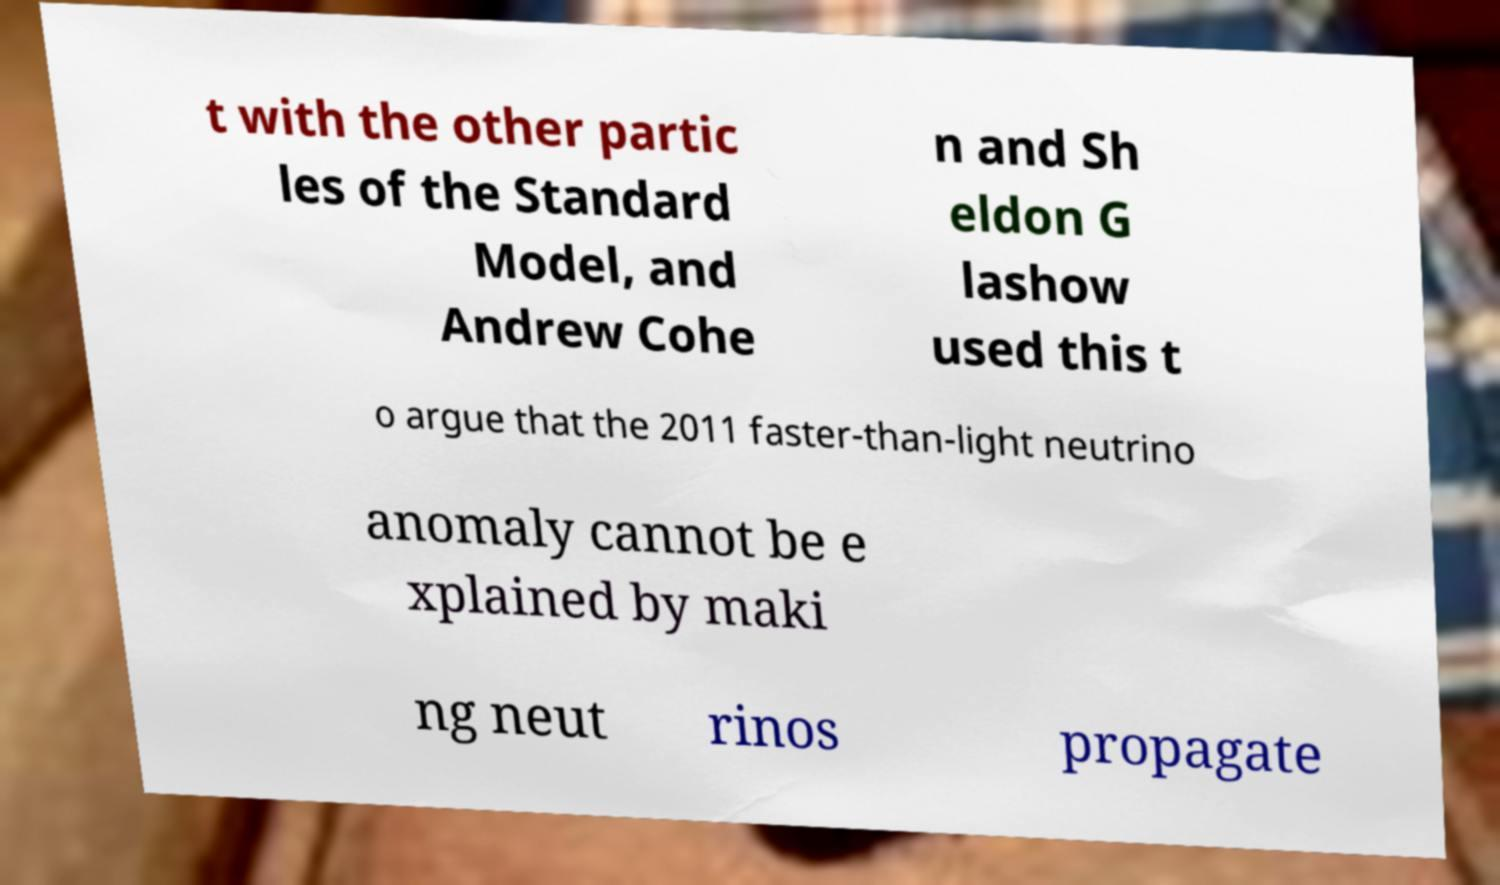There's text embedded in this image that I need extracted. Can you transcribe it verbatim? t with the other partic les of the Standard Model, and Andrew Cohe n and Sh eldon G lashow used this t o argue that the 2011 faster-than-light neutrino anomaly cannot be e xplained by maki ng neut rinos propagate 